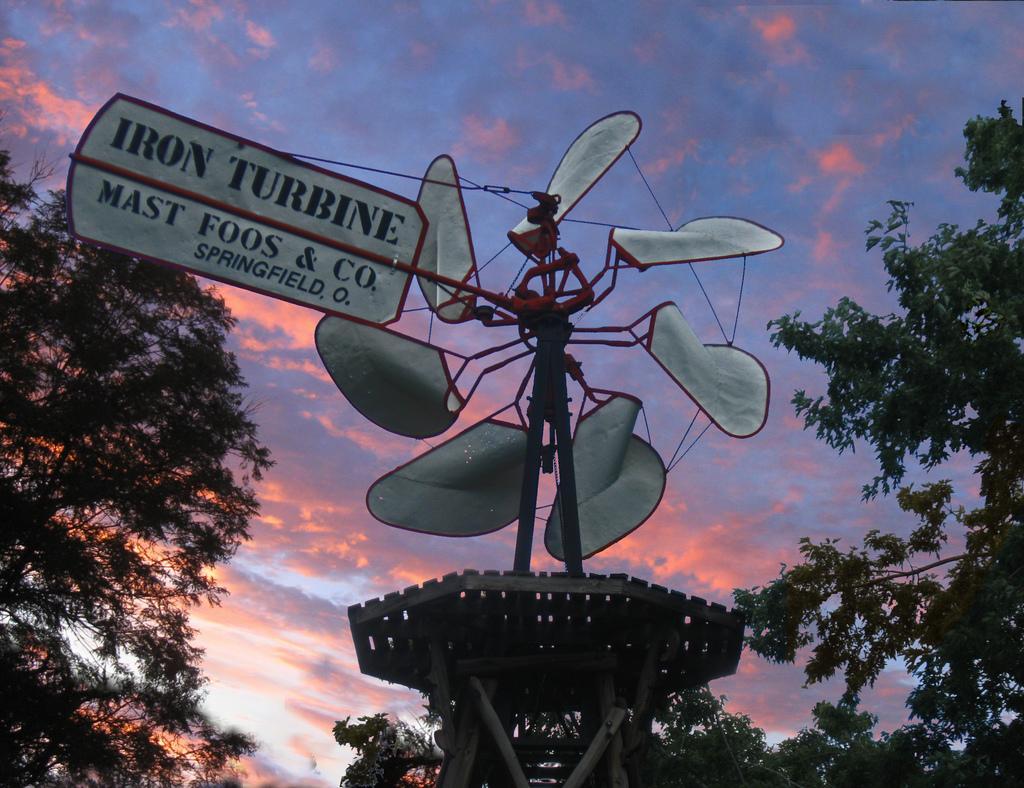Describe this image in one or two sentences. In this image we can see a stand with boards. On the board something is written. On the sides there are trees. In the background there is sky with clouds. 